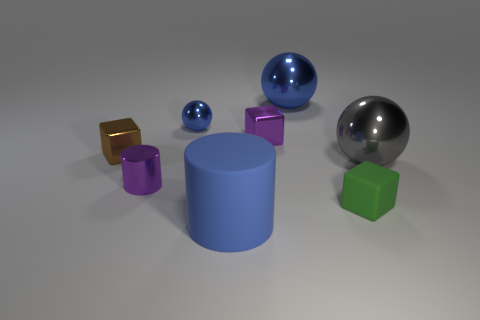There is a blue rubber object; what shape is it?
Make the answer very short. Cylinder. Are there any other things that have the same color as the matte block?
Offer a terse response. No. There is a block that is behind the small brown cube; is its size the same as the purple metallic object in front of the tiny brown object?
Your answer should be very brief. Yes. The big shiny object in front of the blue shiny thing to the right of the big blue cylinder is what shape?
Your answer should be very brief. Sphere. There is a gray object; is its size the same as the cylinder that is behind the small green matte cube?
Keep it short and to the point. No. There is a blue metal ball right of the metallic block that is to the right of the purple object that is on the left side of the big blue matte thing; what is its size?
Provide a succinct answer. Large. How many things are cubes that are behind the brown block or purple metallic blocks?
Your answer should be very brief. 1. There is a big ball that is behind the tiny blue metal ball; how many blue spheres are in front of it?
Offer a terse response. 1. Is the number of blue matte objects that are in front of the large blue matte thing greater than the number of objects?
Offer a terse response. No. How big is the block that is both on the right side of the small brown metal thing and behind the big gray ball?
Provide a short and direct response. Small. 